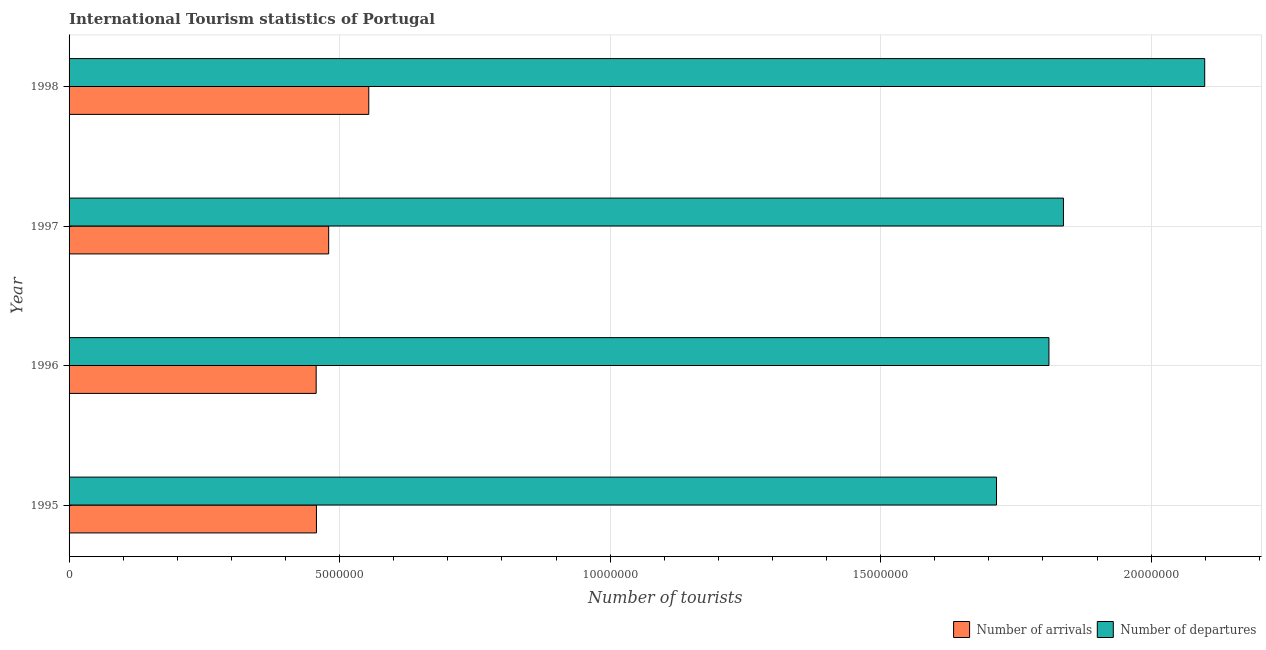How many different coloured bars are there?
Ensure brevity in your answer.  2. How many groups of bars are there?
Provide a succinct answer. 4. Are the number of bars per tick equal to the number of legend labels?
Ensure brevity in your answer.  Yes. How many bars are there on the 4th tick from the bottom?
Keep it short and to the point. 2. What is the label of the 1st group of bars from the top?
Your response must be concise. 1998. In how many cases, is the number of bars for a given year not equal to the number of legend labels?
Give a very brief answer. 0. What is the number of tourist arrivals in 1998?
Ensure brevity in your answer.  5.54e+06. Across all years, what is the maximum number of tourist departures?
Offer a very short reply. 2.10e+07. Across all years, what is the minimum number of tourist arrivals?
Ensure brevity in your answer.  4.57e+06. In which year was the number of tourist departures maximum?
Your answer should be compact. 1998. What is the total number of tourist arrivals in the graph?
Ensure brevity in your answer.  1.95e+07. What is the difference between the number of tourist arrivals in 1996 and that in 1997?
Offer a terse response. -2.31e+05. What is the difference between the number of tourist arrivals in 1998 and the number of tourist departures in 1996?
Your response must be concise. -1.26e+07. What is the average number of tourist arrivals per year?
Make the answer very short. 4.87e+06. In the year 1997, what is the difference between the number of tourist arrivals and number of tourist departures?
Your answer should be compact. -1.36e+07. In how many years, is the number of tourist departures greater than 10000000 ?
Offer a terse response. 4. What is the ratio of the number of tourist departures in 1996 to that in 1998?
Offer a terse response. 0.86. What is the difference between the highest and the second highest number of tourist arrivals?
Offer a very short reply. 7.41e+05. What is the difference between the highest and the lowest number of tourist arrivals?
Provide a succinct answer. 9.72e+05. In how many years, is the number of tourist arrivals greater than the average number of tourist arrivals taken over all years?
Ensure brevity in your answer.  1. Is the sum of the number of tourist departures in 1995 and 1998 greater than the maximum number of tourist arrivals across all years?
Offer a terse response. Yes. What does the 2nd bar from the top in 1998 represents?
Give a very brief answer. Number of arrivals. What does the 2nd bar from the bottom in 1995 represents?
Provide a succinct answer. Number of departures. Are all the bars in the graph horizontal?
Give a very brief answer. Yes. What is the difference between two consecutive major ticks on the X-axis?
Offer a very short reply. 5.00e+06. Are the values on the major ticks of X-axis written in scientific E-notation?
Keep it short and to the point. No. Where does the legend appear in the graph?
Offer a very short reply. Bottom right. How many legend labels are there?
Make the answer very short. 2. How are the legend labels stacked?
Provide a succinct answer. Horizontal. What is the title of the graph?
Ensure brevity in your answer.  International Tourism statistics of Portugal. What is the label or title of the X-axis?
Provide a short and direct response. Number of tourists. What is the label or title of the Y-axis?
Make the answer very short. Year. What is the Number of tourists in Number of arrivals in 1995?
Make the answer very short. 4.57e+06. What is the Number of tourists of Number of departures in 1995?
Give a very brief answer. 1.71e+07. What is the Number of tourists of Number of arrivals in 1996?
Offer a very short reply. 4.57e+06. What is the Number of tourists of Number of departures in 1996?
Offer a very short reply. 1.81e+07. What is the Number of tourists in Number of arrivals in 1997?
Keep it short and to the point. 4.80e+06. What is the Number of tourists of Number of departures in 1997?
Provide a short and direct response. 1.84e+07. What is the Number of tourists of Number of arrivals in 1998?
Ensure brevity in your answer.  5.54e+06. What is the Number of tourists of Number of departures in 1998?
Give a very brief answer. 2.10e+07. Across all years, what is the maximum Number of tourists of Number of arrivals?
Make the answer very short. 5.54e+06. Across all years, what is the maximum Number of tourists of Number of departures?
Give a very brief answer. 2.10e+07. Across all years, what is the minimum Number of tourists in Number of arrivals?
Keep it short and to the point. 4.57e+06. Across all years, what is the minimum Number of tourists of Number of departures?
Your answer should be very brief. 1.71e+07. What is the total Number of tourists of Number of arrivals in the graph?
Keep it short and to the point. 1.95e+07. What is the total Number of tourists of Number of departures in the graph?
Provide a succinct answer. 7.46e+07. What is the difference between the Number of tourists of Number of arrivals in 1995 and that in 1996?
Give a very brief answer. 5000. What is the difference between the Number of tourists of Number of departures in 1995 and that in 1996?
Give a very brief answer. -9.69e+05. What is the difference between the Number of tourists in Number of arrivals in 1995 and that in 1997?
Ensure brevity in your answer.  -2.26e+05. What is the difference between the Number of tourists in Number of departures in 1995 and that in 1997?
Give a very brief answer. -1.24e+06. What is the difference between the Number of tourists in Number of arrivals in 1995 and that in 1998?
Provide a succinct answer. -9.67e+05. What is the difference between the Number of tourists of Number of departures in 1995 and that in 1998?
Your answer should be compact. -3.85e+06. What is the difference between the Number of tourists of Number of arrivals in 1996 and that in 1997?
Keep it short and to the point. -2.31e+05. What is the difference between the Number of tourists of Number of departures in 1996 and that in 1997?
Provide a short and direct response. -2.68e+05. What is the difference between the Number of tourists of Number of arrivals in 1996 and that in 1998?
Your answer should be compact. -9.72e+05. What is the difference between the Number of tourists in Number of departures in 1996 and that in 1998?
Make the answer very short. -2.88e+06. What is the difference between the Number of tourists in Number of arrivals in 1997 and that in 1998?
Your response must be concise. -7.41e+05. What is the difference between the Number of tourists in Number of departures in 1997 and that in 1998?
Provide a succinct answer. -2.61e+06. What is the difference between the Number of tourists in Number of arrivals in 1995 and the Number of tourists in Number of departures in 1996?
Make the answer very short. -1.35e+07. What is the difference between the Number of tourists in Number of arrivals in 1995 and the Number of tourists in Number of departures in 1997?
Your answer should be very brief. -1.38e+07. What is the difference between the Number of tourists in Number of arrivals in 1995 and the Number of tourists in Number of departures in 1998?
Make the answer very short. -1.64e+07. What is the difference between the Number of tourists of Number of arrivals in 1996 and the Number of tourists of Number of departures in 1997?
Your answer should be compact. -1.38e+07. What is the difference between the Number of tourists of Number of arrivals in 1996 and the Number of tourists of Number of departures in 1998?
Make the answer very short. -1.64e+07. What is the difference between the Number of tourists of Number of arrivals in 1997 and the Number of tourists of Number of departures in 1998?
Make the answer very short. -1.62e+07. What is the average Number of tourists in Number of arrivals per year?
Give a very brief answer. 4.87e+06. What is the average Number of tourists in Number of departures per year?
Make the answer very short. 1.87e+07. In the year 1995, what is the difference between the Number of tourists of Number of arrivals and Number of tourists of Number of departures?
Your answer should be compact. -1.26e+07. In the year 1996, what is the difference between the Number of tourists of Number of arrivals and Number of tourists of Number of departures?
Give a very brief answer. -1.35e+07. In the year 1997, what is the difference between the Number of tourists in Number of arrivals and Number of tourists in Number of departures?
Make the answer very short. -1.36e+07. In the year 1998, what is the difference between the Number of tourists of Number of arrivals and Number of tourists of Number of departures?
Give a very brief answer. -1.54e+07. What is the ratio of the Number of tourists in Number of arrivals in 1995 to that in 1996?
Make the answer very short. 1. What is the ratio of the Number of tourists of Number of departures in 1995 to that in 1996?
Your response must be concise. 0.95. What is the ratio of the Number of tourists in Number of arrivals in 1995 to that in 1997?
Give a very brief answer. 0.95. What is the ratio of the Number of tourists in Number of departures in 1995 to that in 1997?
Your answer should be compact. 0.93. What is the ratio of the Number of tourists in Number of arrivals in 1995 to that in 1998?
Offer a terse response. 0.83. What is the ratio of the Number of tourists in Number of departures in 1995 to that in 1998?
Give a very brief answer. 0.82. What is the ratio of the Number of tourists in Number of arrivals in 1996 to that in 1997?
Your answer should be very brief. 0.95. What is the ratio of the Number of tourists in Number of departures in 1996 to that in 1997?
Give a very brief answer. 0.99. What is the ratio of the Number of tourists in Number of arrivals in 1996 to that in 1998?
Provide a short and direct response. 0.82. What is the ratio of the Number of tourists in Number of departures in 1996 to that in 1998?
Your answer should be very brief. 0.86. What is the ratio of the Number of tourists of Number of arrivals in 1997 to that in 1998?
Keep it short and to the point. 0.87. What is the ratio of the Number of tourists in Number of departures in 1997 to that in 1998?
Make the answer very short. 0.88. What is the difference between the highest and the second highest Number of tourists of Number of arrivals?
Your response must be concise. 7.41e+05. What is the difference between the highest and the second highest Number of tourists of Number of departures?
Ensure brevity in your answer.  2.61e+06. What is the difference between the highest and the lowest Number of tourists in Number of arrivals?
Make the answer very short. 9.72e+05. What is the difference between the highest and the lowest Number of tourists of Number of departures?
Provide a succinct answer. 3.85e+06. 